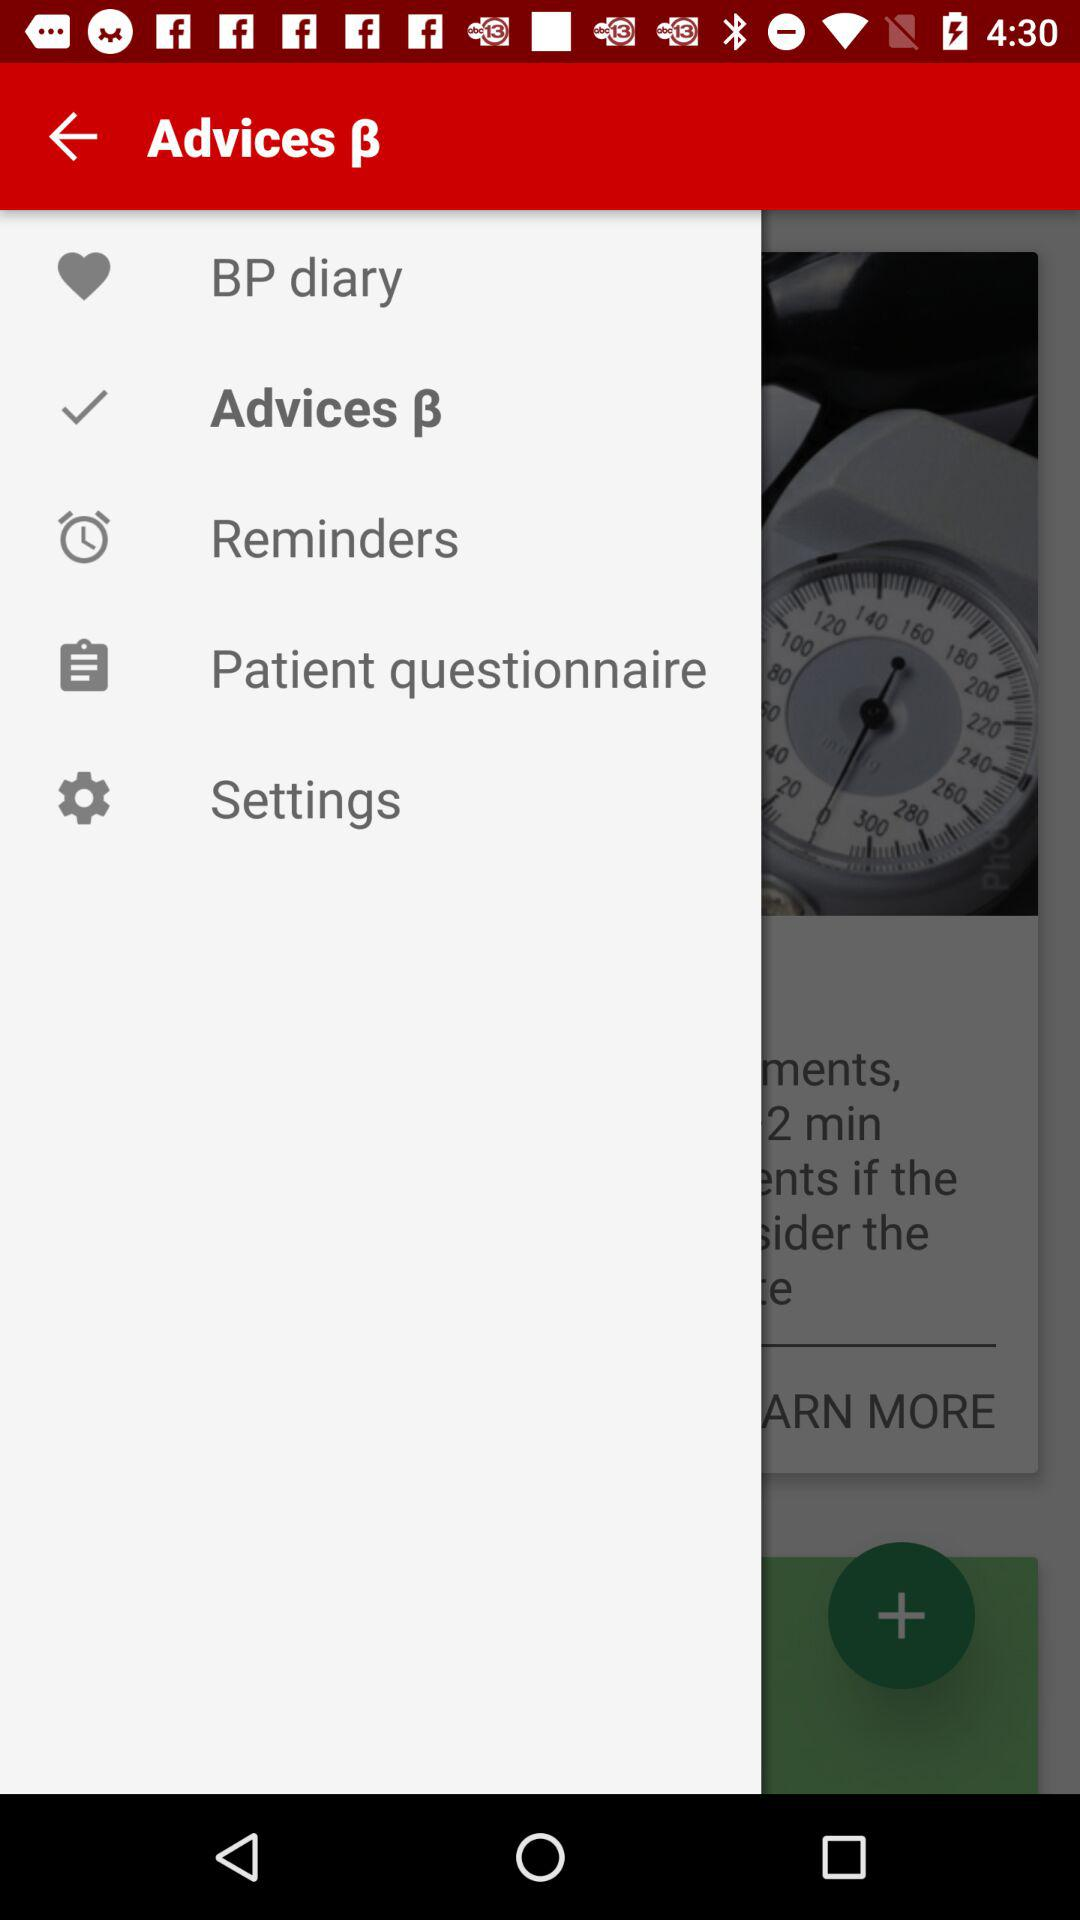What is the selected option? The selected option is "Advices ẞ". 